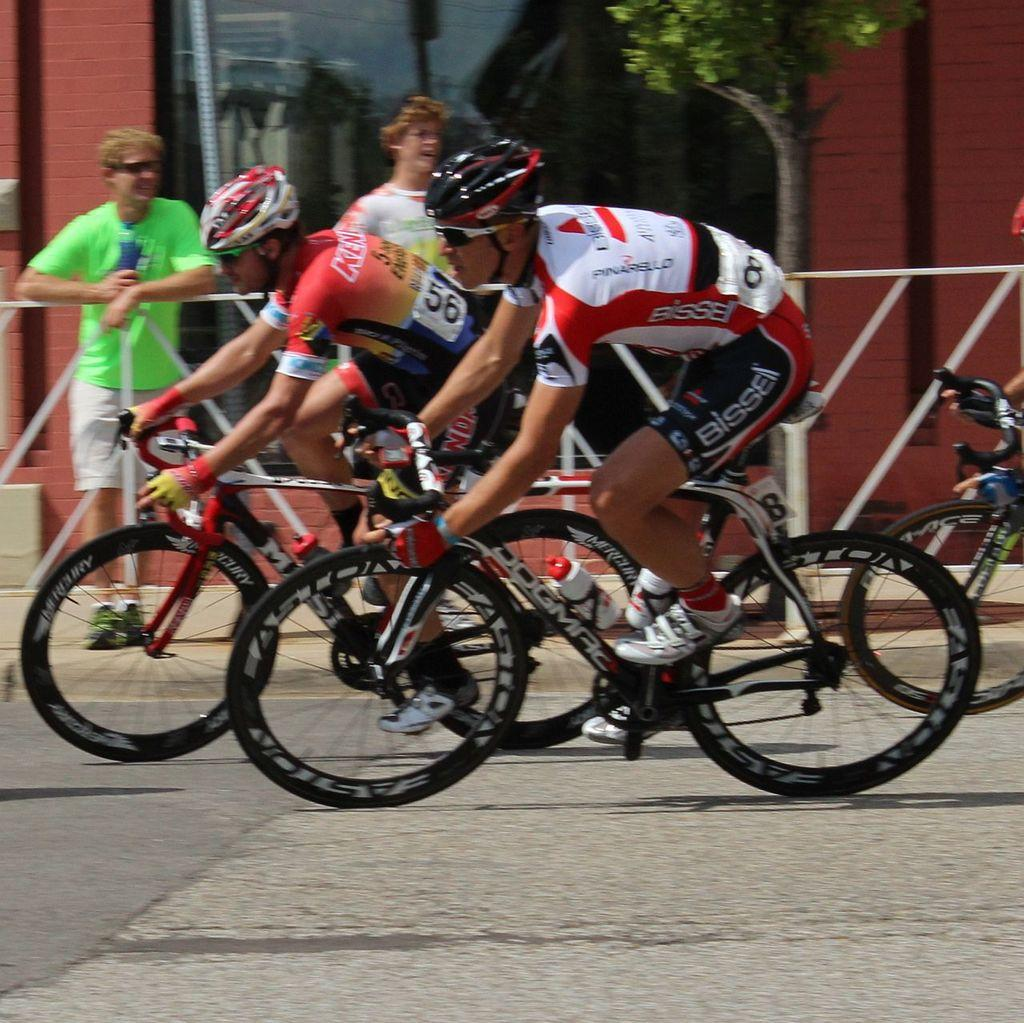How many people are in the image? There are two people in the image. What are the two people wearing? The two people are wearing helmets. What activity are the two people engaged in? The two people are riding bicycles. What can be seen on the side of the road in the image? There are two people standing on the footpath. What type of vegetation is present in the image? There is a tree in the image. What is the governor's opinion on the taste of the bicycles in the image? There is no governor present in the image, and bicycles do not have a taste. 